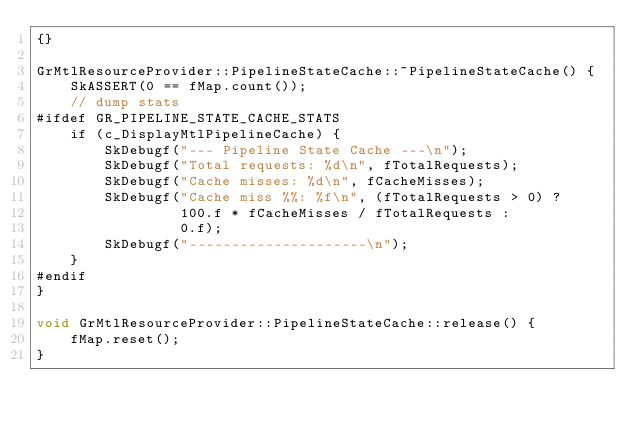Convert code to text. <code><loc_0><loc_0><loc_500><loc_500><_ObjectiveC_>{}

GrMtlResourceProvider::PipelineStateCache::~PipelineStateCache() {
    SkASSERT(0 == fMap.count());
    // dump stats
#ifdef GR_PIPELINE_STATE_CACHE_STATS
    if (c_DisplayMtlPipelineCache) {
        SkDebugf("--- Pipeline State Cache ---\n");
        SkDebugf("Total requests: %d\n", fTotalRequests);
        SkDebugf("Cache misses: %d\n", fCacheMisses);
        SkDebugf("Cache miss %%: %f\n", (fTotalRequests > 0) ?
                 100.f * fCacheMisses / fTotalRequests :
                 0.f);
        SkDebugf("---------------------\n");
    }
#endif
}

void GrMtlResourceProvider::PipelineStateCache::release() {
    fMap.reset();
}
</code> 